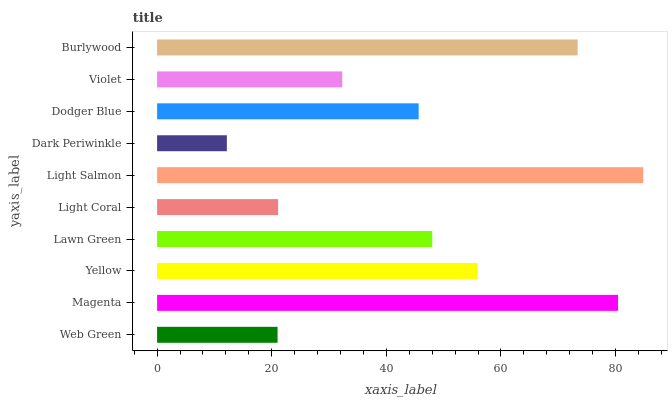Is Dark Periwinkle the minimum?
Answer yes or no. Yes. Is Light Salmon the maximum?
Answer yes or no. Yes. Is Magenta the minimum?
Answer yes or no. No. Is Magenta the maximum?
Answer yes or no. No. Is Magenta greater than Web Green?
Answer yes or no. Yes. Is Web Green less than Magenta?
Answer yes or no. Yes. Is Web Green greater than Magenta?
Answer yes or no. No. Is Magenta less than Web Green?
Answer yes or no. No. Is Lawn Green the high median?
Answer yes or no. Yes. Is Dodger Blue the low median?
Answer yes or no. Yes. Is Dark Periwinkle the high median?
Answer yes or no. No. Is Web Green the low median?
Answer yes or no. No. 